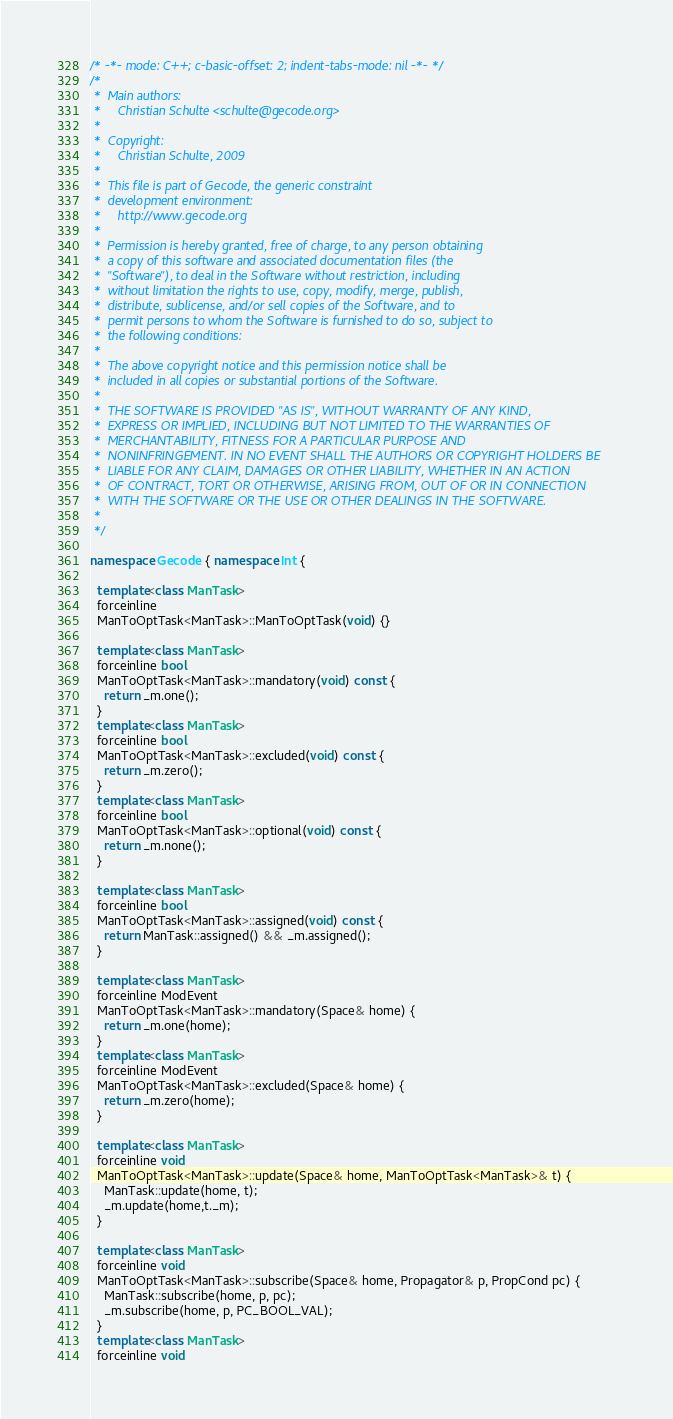<code> <loc_0><loc_0><loc_500><loc_500><_C++_>/* -*- mode: C++; c-basic-offset: 2; indent-tabs-mode: nil -*- */
/*
 *  Main authors:
 *     Christian Schulte <schulte@gecode.org>
 *
 *  Copyright:
 *     Christian Schulte, 2009
 *
 *  This file is part of Gecode, the generic constraint
 *  development environment:
 *     http://www.gecode.org
 *
 *  Permission is hereby granted, free of charge, to any person obtaining
 *  a copy of this software and associated documentation files (the
 *  "Software"), to deal in the Software without restriction, including
 *  without limitation the rights to use, copy, modify, merge, publish,
 *  distribute, sublicense, and/or sell copies of the Software, and to
 *  permit persons to whom the Software is furnished to do so, subject to
 *  the following conditions:
 *
 *  The above copyright notice and this permission notice shall be
 *  included in all copies or substantial portions of the Software.
 *
 *  THE SOFTWARE IS PROVIDED "AS IS", WITHOUT WARRANTY OF ANY KIND,
 *  EXPRESS OR IMPLIED, INCLUDING BUT NOT LIMITED TO THE WARRANTIES OF
 *  MERCHANTABILITY, FITNESS FOR A PARTICULAR PURPOSE AND
 *  NONINFRINGEMENT. IN NO EVENT SHALL THE AUTHORS OR COPYRIGHT HOLDERS BE
 *  LIABLE FOR ANY CLAIM, DAMAGES OR OTHER LIABILITY, WHETHER IN AN ACTION
 *  OF CONTRACT, TORT OR OTHERWISE, ARISING FROM, OUT OF OR IN CONNECTION
 *  WITH THE SOFTWARE OR THE USE OR OTHER DEALINGS IN THE SOFTWARE.
 *
 */

namespace Gecode { namespace Int {

  template<class ManTask>
  forceinline
  ManToOptTask<ManTask>::ManToOptTask(void) {}

  template<class ManTask>
  forceinline bool
  ManToOptTask<ManTask>::mandatory(void) const {
    return _m.one();
  }
  template<class ManTask>
  forceinline bool
  ManToOptTask<ManTask>::excluded(void) const {
    return _m.zero();
  }
  template<class ManTask>
  forceinline bool
  ManToOptTask<ManTask>::optional(void) const {
    return _m.none();
  }

  template<class ManTask>
  forceinline bool
  ManToOptTask<ManTask>::assigned(void) const {
    return ManTask::assigned() && _m.assigned();
  }

  template<class ManTask>
  forceinline ModEvent
  ManToOptTask<ManTask>::mandatory(Space& home) {
    return _m.one(home);
  }
  template<class ManTask>
  forceinline ModEvent
  ManToOptTask<ManTask>::excluded(Space& home) {
    return _m.zero(home);
  }

  template<class ManTask>
  forceinline void
  ManToOptTask<ManTask>::update(Space& home, ManToOptTask<ManTask>& t) {
    ManTask::update(home, t);
    _m.update(home,t._m);
  }

  template<class ManTask>
  forceinline void
  ManToOptTask<ManTask>::subscribe(Space& home, Propagator& p, PropCond pc) {
    ManTask::subscribe(home, p, pc);
    _m.subscribe(home, p, PC_BOOL_VAL);
  }
  template<class ManTask>
  forceinline void</code> 